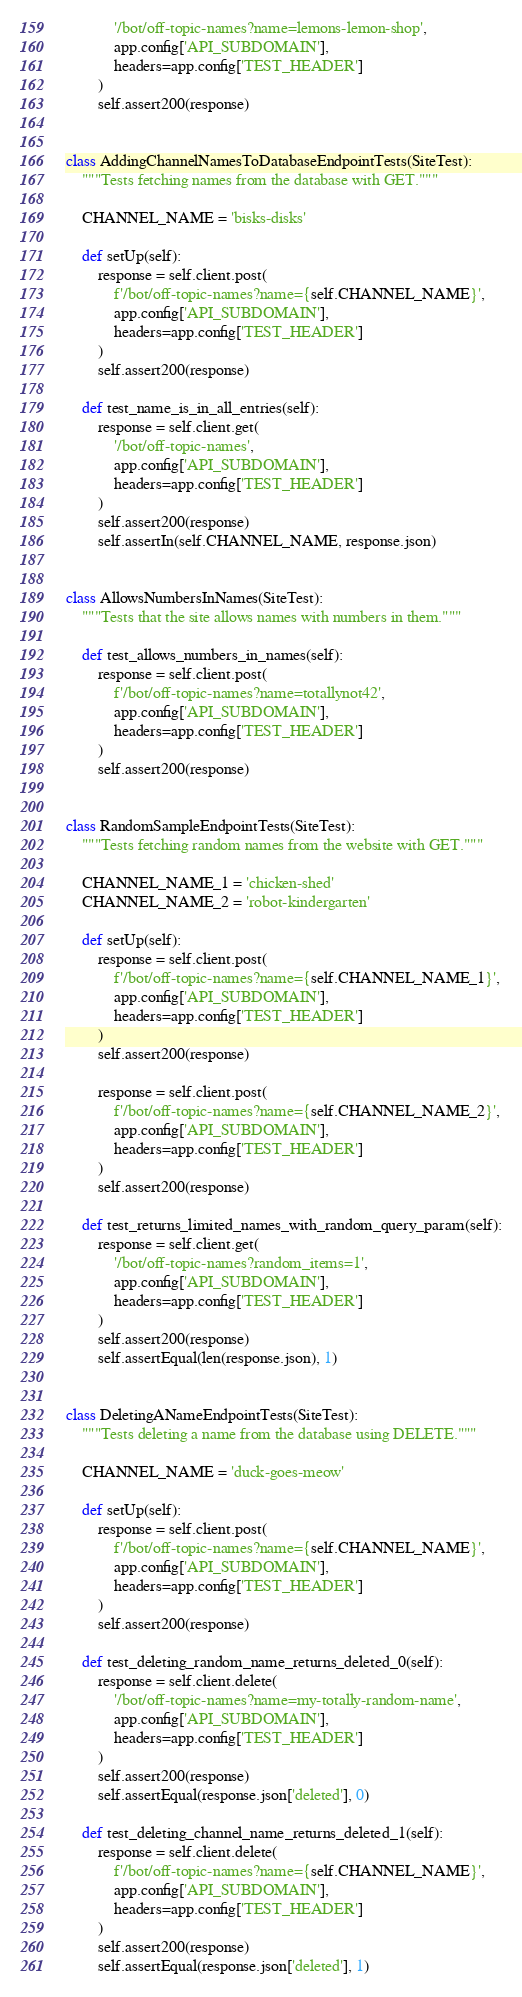Convert code to text. <code><loc_0><loc_0><loc_500><loc_500><_Python_>            '/bot/off-topic-names?name=lemons-lemon-shop',
            app.config['API_SUBDOMAIN'],
            headers=app.config['TEST_HEADER']
        )
        self.assert200(response)


class AddingChannelNamesToDatabaseEndpointTests(SiteTest):
    """Tests fetching names from the database with GET."""

    CHANNEL_NAME = 'bisks-disks'

    def setUp(self):
        response = self.client.post(
            f'/bot/off-topic-names?name={self.CHANNEL_NAME}',
            app.config['API_SUBDOMAIN'],
            headers=app.config['TEST_HEADER']
        )
        self.assert200(response)

    def test_name_is_in_all_entries(self):
        response = self.client.get(
            '/bot/off-topic-names',
            app.config['API_SUBDOMAIN'],
            headers=app.config['TEST_HEADER']
        )
        self.assert200(response)
        self.assertIn(self.CHANNEL_NAME, response.json)


class AllowsNumbersInNames(SiteTest):
    """Tests that the site allows names with numbers in them."""

    def test_allows_numbers_in_names(self):
        response = self.client.post(
            f'/bot/off-topic-names?name=totallynot42',
            app.config['API_SUBDOMAIN'],
            headers=app.config['TEST_HEADER']
        )
        self.assert200(response)


class RandomSampleEndpointTests(SiteTest):
    """Tests fetching random names from the website with GET."""

    CHANNEL_NAME_1 = 'chicken-shed'
    CHANNEL_NAME_2 = 'robot-kindergarten'

    def setUp(self):
        response = self.client.post(
            f'/bot/off-topic-names?name={self.CHANNEL_NAME_1}',
            app.config['API_SUBDOMAIN'],
            headers=app.config['TEST_HEADER']
        )
        self.assert200(response)

        response = self.client.post(
            f'/bot/off-topic-names?name={self.CHANNEL_NAME_2}',
            app.config['API_SUBDOMAIN'],
            headers=app.config['TEST_HEADER']
        )
        self.assert200(response)

    def test_returns_limited_names_with_random_query_param(self):
        response = self.client.get(
            '/bot/off-topic-names?random_items=1',
            app.config['API_SUBDOMAIN'],
            headers=app.config['TEST_HEADER']
        )
        self.assert200(response)
        self.assertEqual(len(response.json), 1)


class DeletingANameEndpointTests(SiteTest):
    """Tests deleting a name from the database using DELETE."""

    CHANNEL_NAME = 'duck-goes-meow'

    def setUp(self):
        response = self.client.post(
            f'/bot/off-topic-names?name={self.CHANNEL_NAME}',
            app.config['API_SUBDOMAIN'],
            headers=app.config['TEST_HEADER']
        )
        self.assert200(response)

    def test_deleting_random_name_returns_deleted_0(self):
        response = self.client.delete(
            '/bot/off-topic-names?name=my-totally-random-name',
            app.config['API_SUBDOMAIN'],
            headers=app.config['TEST_HEADER']
        )
        self.assert200(response)
        self.assertEqual(response.json['deleted'], 0)

    def test_deleting_channel_name_returns_deleted_1(self):
        response = self.client.delete(
            f'/bot/off-topic-names?name={self.CHANNEL_NAME}',
            app.config['API_SUBDOMAIN'],
            headers=app.config['TEST_HEADER']
        )
        self.assert200(response)
        self.assertEqual(response.json['deleted'], 1)
</code> 